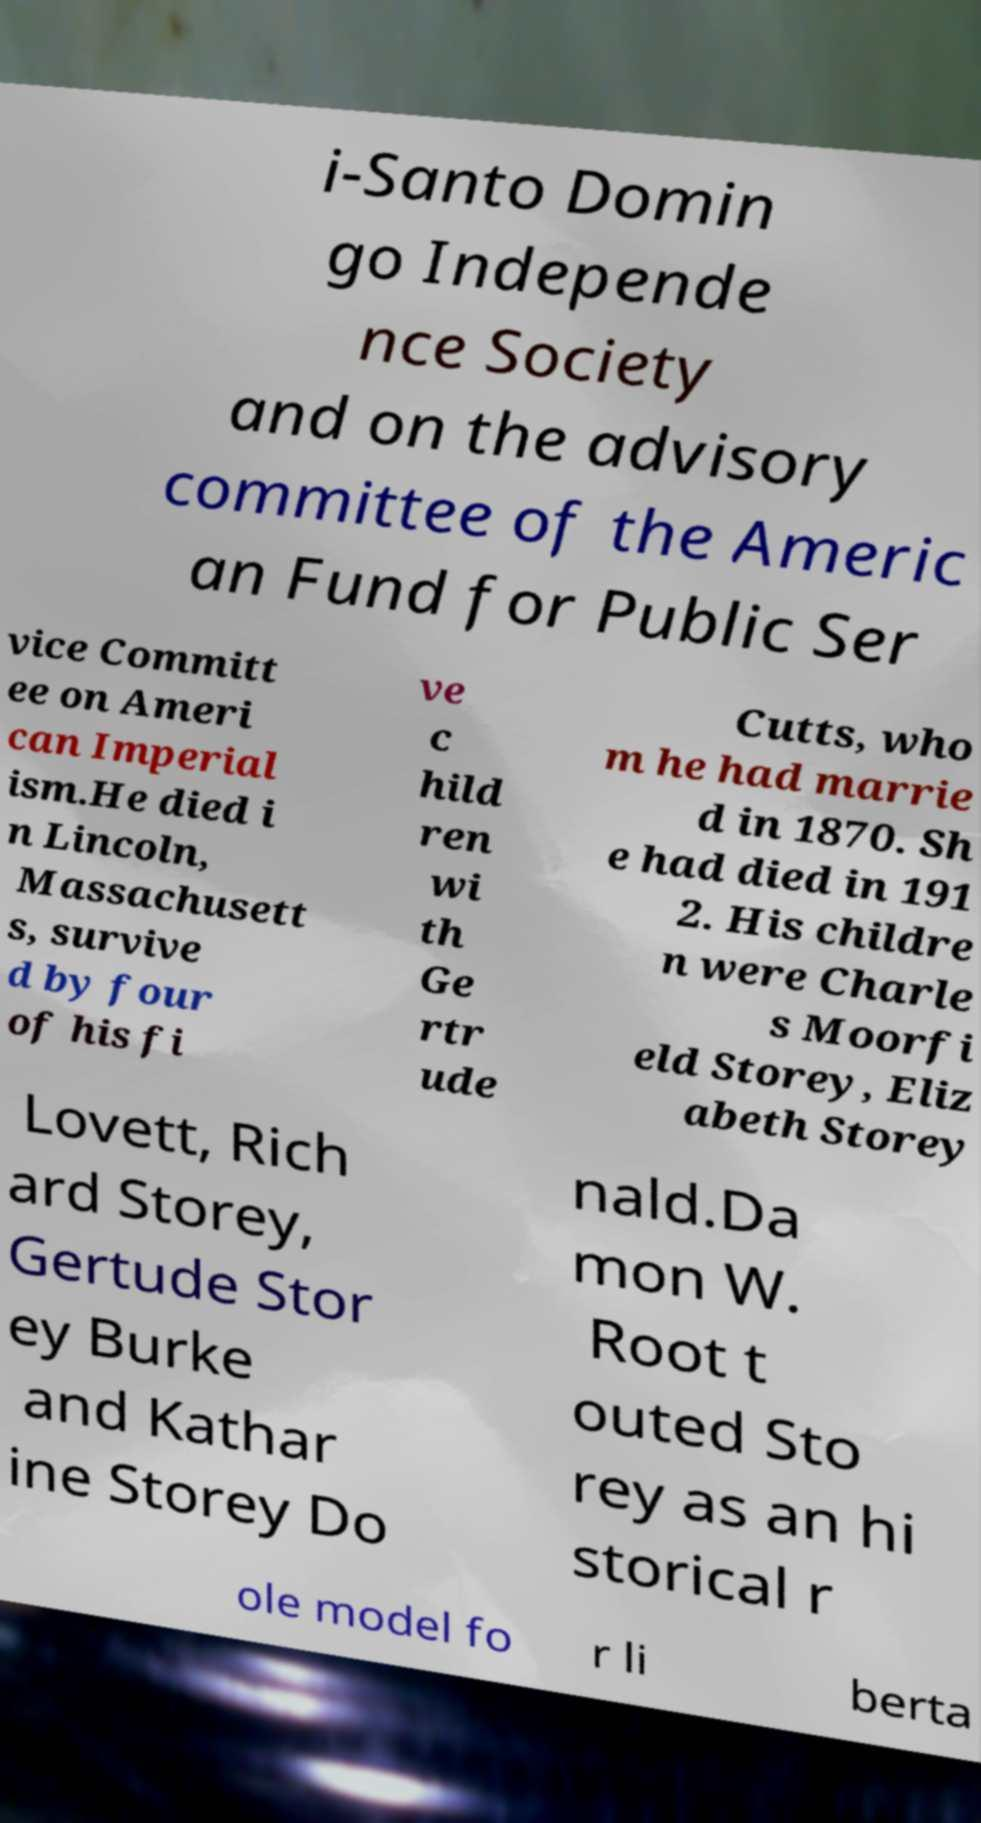Can you read and provide the text displayed in the image?This photo seems to have some interesting text. Can you extract and type it out for me? i-Santo Domin go Independe nce Society and on the advisory committee of the Americ an Fund for Public Ser vice Committ ee on Ameri can Imperial ism.He died i n Lincoln, Massachusett s, survive d by four of his fi ve c hild ren wi th Ge rtr ude Cutts, who m he had marrie d in 1870. Sh e had died in 191 2. His childre n were Charle s Moorfi eld Storey, Eliz abeth Storey Lovett, Rich ard Storey, Gertude Stor ey Burke and Kathar ine Storey Do nald.Da mon W. Root t outed Sto rey as an hi storical r ole model fo r li berta 